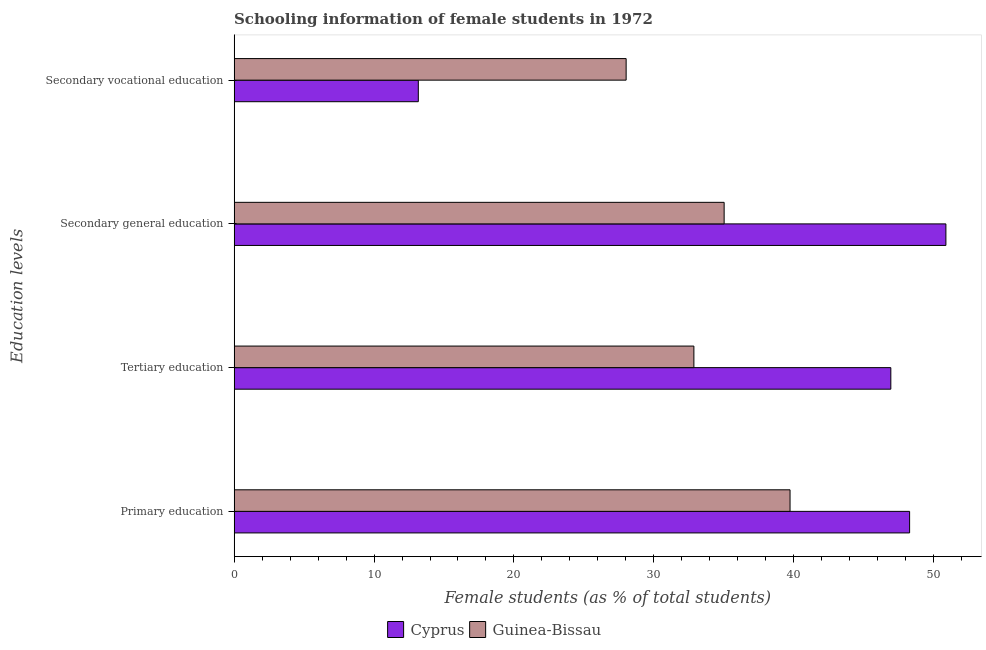How many different coloured bars are there?
Provide a succinct answer. 2. How many groups of bars are there?
Your answer should be compact. 4. Are the number of bars per tick equal to the number of legend labels?
Make the answer very short. Yes. How many bars are there on the 3rd tick from the top?
Offer a very short reply. 2. How many bars are there on the 1st tick from the bottom?
Offer a terse response. 2. What is the label of the 1st group of bars from the top?
Provide a short and direct response. Secondary vocational education. What is the percentage of female students in secondary education in Cyprus?
Offer a very short reply. 50.87. Across all countries, what is the maximum percentage of female students in primary education?
Your answer should be very brief. 48.28. Across all countries, what is the minimum percentage of female students in secondary vocational education?
Provide a short and direct response. 13.16. In which country was the percentage of female students in primary education maximum?
Provide a short and direct response. Cyprus. In which country was the percentage of female students in primary education minimum?
Make the answer very short. Guinea-Bissau. What is the total percentage of female students in tertiary education in the graph?
Provide a succinct answer. 79.8. What is the difference between the percentage of female students in secondary vocational education in Cyprus and that in Guinea-Bissau?
Ensure brevity in your answer.  -14.85. What is the difference between the percentage of female students in tertiary education in Cyprus and the percentage of female students in secondary education in Guinea-Bissau?
Your answer should be compact. 11.91. What is the average percentage of female students in secondary education per country?
Your answer should be very brief. 42.95. What is the difference between the percentage of female students in secondary education and percentage of female students in tertiary education in Cyprus?
Ensure brevity in your answer.  3.94. In how many countries, is the percentage of female students in secondary education greater than 8 %?
Your answer should be compact. 2. What is the ratio of the percentage of female students in primary education in Guinea-Bissau to that in Cyprus?
Offer a terse response. 0.82. What is the difference between the highest and the second highest percentage of female students in tertiary education?
Give a very brief answer. 14.08. What is the difference between the highest and the lowest percentage of female students in tertiary education?
Provide a succinct answer. 14.08. In how many countries, is the percentage of female students in tertiary education greater than the average percentage of female students in tertiary education taken over all countries?
Provide a short and direct response. 1. Is it the case that in every country, the sum of the percentage of female students in tertiary education and percentage of female students in secondary vocational education is greater than the sum of percentage of female students in secondary education and percentage of female students in primary education?
Your answer should be compact. No. What does the 2nd bar from the top in Secondary general education represents?
Ensure brevity in your answer.  Cyprus. What does the 1st bar from the bottom in Tertiary education represents?
Offer a terse response. Cyprus. Is it the case that in every country, the sum of the percentage of female students in primary education and percentage of female students in tertiary education is greater than the percentage of female students in secondary education?
Give a very brief answer. Yes. How many bars are there?
Provide a succinct answer. 8. Are all the bars in the graph horizontal?
Provide a short and direct response. Yes. What is the difference between two consecutive major ticks on the X-axis?
Your answer should be very brief. 10. Are the values on the major ticks of X-axis written in scientific E-notation?
Make the answer very short. No. How many legend labels are there?
Keep it short and to the point. 2. How are the legend labels stacked?
Offer a very short reply. Horizontal. What is the title of the graph?
Offer a terse response. Schooling information of female students in 1972. Does "Chile" appear as one of the legend labels in the graph?
Provide a succinct answer. No. What is the label or title of the X-axis?
Give a very brief answer. Female students (as % of total students). What is the label or title of the Y-axis?
Offer a very short reply. Education levels. What is the Female students (as % of total students) of Cyprus in Primary education?
Keep it short and to the point. 48.28. What is the Female students (as % of total students) of Guinea-Bissau in Primary education?
Your answer should be compact. 39.73. What is the Female students (as % of total students) of Cyprus in Tertiary education?
Keep it short and to the point. 46.94. What is the Female students (as % of total students) in Guinea-Bissau in Tertiary education?
Offer a very short reply. 32.86. What is the Female students (as % of total students) of Cyprus in Secondary general education?
Offer a terse response. 50.87. What is the Female students (as % of total students) in Guinea-Bissau in Secondary general education?
Give a very brief answer. 35.02. What is the Female students (as % of total students) in Cyprus in Secondary vocational education?
Give a very brief answer. 13.16. What is the Female students (as % of total students) of Guinea-Bissau in Secondary vocational education?
Give a very brief answer. 28.02. Across all Education levels, what is the maximum Female students (as % of total students) in Cyprus?
Your answer should be very brief. 50.87. Across all Education levels, what is the maximum Female students (as % of total students) in Guinea-Bissau?
Ensure brevity in your answer.  39.73. Across all Education levels, what is the minimum Female students (as % of total students) of Cyprus?
Provide a succinct answer. 13.16. Across all Education levels, what is the minimum Female students (as % of total students) of Guinea-Bissau?
Your answer should be very brief. 28.02. What is the total Female students (as % of total students) in Cyprus in the graph?
Your answer should be very brief. 159.26. What is the total Female students (as % of total students) of Guinea-Bissau in the graph?
Offer a very short reply. 135.64. What is the difference between the Female students (as % of total students) of Cyprus in Primary education and that in Tertiary education?
Give a very brief answer. 1.34. What is the difference between the Female students (as % of total students) in Guinea-Bissau in Primary education and that in Tertiary education?
Give a very brief answer. 6.87. What is the difference between the Female students (as % of total students) of Cyprus in Primary education and that in Secondary general education?
Make the answer very short. -2.59. What is the difference between the Female students (as % of total students) in Guinea-Bissau in Primary education and that in Secondary general education?
Offer a terse response. 4.71. What is the difference between the Female students (as % of total students) of Cyprus in Primary education and that in Secondary vocational education?
Make the answer very short. 35.12. What is the difference between the Female students (as % of total students) of Guinea-Bissau in Primary education and that in Secondary vocational education?
Keep it short and to the point. 11.71. What is the difference between the Female students (as % of total students) in Cyprus in Tertiary education and that in Secondary general education?
Make the answer very short. -3.94. What is the difference between the Female students (as % of total students) of Guinea-Bissau in Tertiary education and that in Secondary general education?
Offer a terse response. -2.16. What is the difference between the Female students (as % of total students) of Cyprus in Tertiary education and that in Secondary vocational education?
Your answer should be very brief. 33.77. What is the difference between the Female students (as % of total students) in Guinea-Bissau in Tertiary education and that in Secondary vocational education?
Your response must be concise. 4.84. What is the difference between the Female students (as % of total students) in Cyprus in Secondary general education and that in Secondary vocational education?
Ensure brevity in your answer.  37.71. What is the difference between the Female students (as % of total students) of Guinea-Bissau in Secondary general education and that in Secondary vocational education?
Offer a very short reply. 7. What is the difference between the Female students (as % of total students) in Cyprus in Primary education and the Female students (as % of total students) in Guinea-Bissau in Tertiary education?
Offer a very short reply. 15.42. What is the difference between the Female students (as % of total students) of Cyprus in Primary education and the Female students (as % of total students) of Guinea-Bissau in Secondary general education?
Give a very brief answer. 13.26. What is the difference between the Female students (as % of total students) of Cyprus in Primary education and the Female students (as % of total students) of Guinea-Bissau in Secondary vocational education?
Your answer should be compact. 20.26. What is the difference between the Female students (as % of total students) of Cyprus in Tertiary education and the Female students (as % of total students) of Guinea-Bissau in Secondary general education?
Your response must be concise. 11.91. What is the difference between the Female students (as % of total students) of Cyprus in Tertiary education and the Female students (as % of total students) of Guinea-Bissau in Secondary vocational education?
Keep it short and to the point. 18.92. What is the difference between the Female students (as % of total students) of Cyprus in Secondary general education and the Female students (as % of total students) of Guinea-Bissau in Secondary vocational education?
Ensure brevity in your answer.  22.85. What is the average Female students (as % of total students) in Cyprus per Education levels?
Keep it short and to the point. 39.81. What is the average Female students (as % of total students) of Guinea-Bissau per Education levels?
Keep it short and to the point. 33.91. What is the difference between the Female students (as % of total students) of Cyprus and Female students (as % of total students) of Guinea-Bissau in Primary education?
Your response must be concise. 8.55. What is the difference between the Female students (as % of total students) in Cyprus and Female students (as % of total students) in Guinea-Bissau in Tertiary education?
Provide a succinct answer. 14.08. What is the difference between the Female students (as % of total students) in Cyprus and Female students (as % of total students) in Guinea-Bissau in Secondary general education?
Keep it short and to the point. 15.85. What is the difference between the Female students (as % of total students) of Cyprus and Female students (as % of total students) of Guinea-Bissau in Secondary vocational education?
Keep it short and to the point. -14.85. What is the ratio of the Female students (as % of total students) of Cyprus in Primary education to that in Tertiary education?
Offer a very short reply. 1.03. What is the ratio of the Female students (as % of total students) in Guinea-Bissau in Primary education to that in Tertiary education?
Offer a terse response. 1.21. What is the ratio of the Female students (as % of total students) in Cyprus in Primary education to that in Secondary general education?
Your answer should be compact. 0.95. What is the ratio of the Female students (as % of total students) of Guinea-Bissau in Primary education to that in Secondary general education?
Your answer should be very brief. 1.13. What is the ratio of the Female students (as % of total students) in Cyprus in Primary education to that in Secondary vocational education?
Provide a short and direct response. 3.67. What is the ratio of the Female students (as % of total students) in Guinea-Bissau in Primary education to that in Secondary vocational education?
Ensure brevity in your answer.  1.42. What is the ratio of the Female students (as % of total students) in Cyprus in Tertiary education to that in Secondary general education?
Give a very brief answer. 0.92. What is the ratio of the Female students (as % of total students) in Guinea-Bissau in Tertiary education to that in Secondary general education?
Ensure brevity in your answer.  0.94. What is the ratio of the Female students (as % of total students) in Cyprus in Tertiary education to that in Secondary vocational education?
Offer a very short reply. 3.57. What is the ratio of the Female students (as % of total students) of Guinea-Bissau in Tertiary education to that in Secondary vocational education?
Ensure brevity in your answer.  1.17. What is the ratio of the Female students (as % of total students) of Cyprus in Secondary general education to that in Secondary vocational education?
Keep it short and to the point. 3.86. What is the ratio of the Female students (as % of total students) of Guinea-Bissau in Secondary general education to that in Secondary vocational education?
Offer a very short reply. 1.25. What is the difference between the highest and the second highest Female students (as % of total students) in Cyprus?
Your answer should be compact. 2.59. What is the difference between the highest and the second highest Female students (as % of total students) of Guinea-Bissau?
Your answer should be compact. 4.71. What is the difference between the highest and the lowest Female students (as % of total students) of Cyprus?
Your response must be concise. 37.71. What is the difference between the highest and the lowest Female students (as % of total students) of Guinea-Bissau?
Provide a short and direct response. 11.71. 